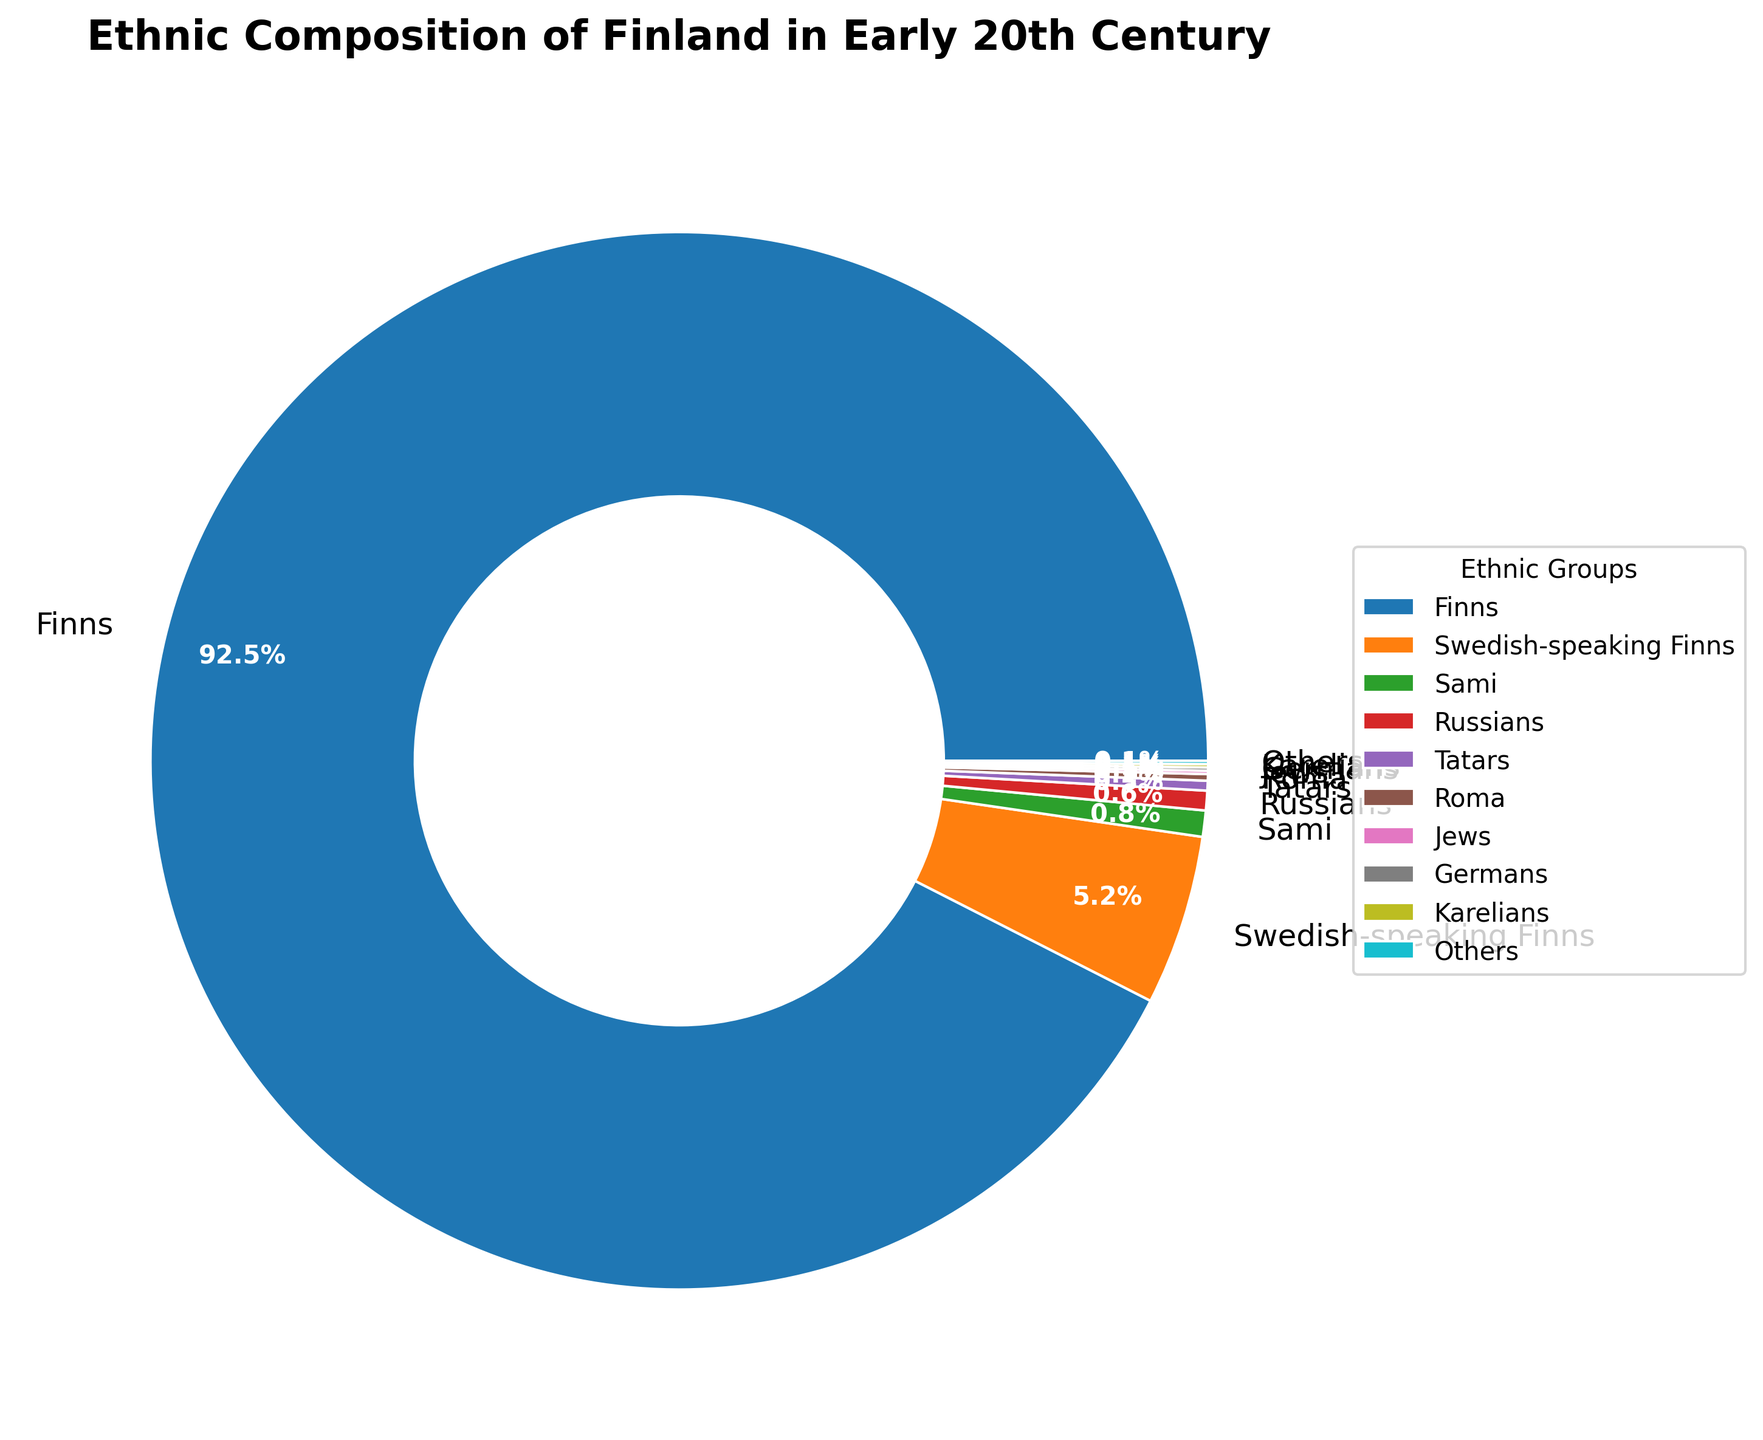What is the percentage of Finns in the ethnic composition of Finland in the early 20th century? The pie chart shows the "Finns" occupying the largest segment with a percentage label of 92.5%.
Answer: 92.5% How does the percentage of Swedish-speaking Finns compare to that of Sami? From the figure, it can be seen that the Swedish-speaking Finns make up 5.2%, while the Sami make up 0.8%. Therefore, the percentage of Swedish-speaking Finns is higher.
Answer: Swedish-speaking Finns have a higher percentage Which ethnic group follows the Finns in terms of population percentage? The pie chart indicates that after the Finns, who have the largest share, the Swedish-speaking Finns have the next largest share at 5.2%.
Answer: Swedish-speaking Finns What is the sum of the percentages of the smallest three ethnic groups? The smallest three groups represented on the chart, each at 0.1%, are Jews, Germans, and Karelians. Summing these gives 0.1% + 0.1% + 0.1% = 0.3%.
Answer: 0.3% How much more is the percentage of Finns compared to Russians? The percentage of Finns is 92.5%, and that of Russians is 0.6%. The difference is calculated as 92.5% - 0.6% = 91.9%.
Answer: 91.9% Which color represents the Tatars in the pie chart? The slice representing the Tatars is colored in a specific shade distinct from the other groups. In the chart's legend or visual representation, Tatars are indicated with a brownish color.
Answer: Brownish color If the percentage of Finns and Swedish-speaking Finns is combined, what fraction of the total population do they represent? Finns make up 92.5% and Swedish-speaking Finns 5.2%. Their combined percentage is 92.5% + 5.2% = 97.7%.
Answer: 97.7% Which ethnic group occupies the smallest segment in the pie chart? Multiple groups occupy 0.1% each, and thus share the smallest segment size equally. These groups are Jews, Germans, Karelians, and Others.
Answer: Jews, Germans, Karelians, Others What is the difference in the percentage between the largest and second-largest ethnic groups? The largest group is Finns at 92.5%, and the second-largest is Swedish-speaking Finns at 5.2%. The difference is 92.5% - 5.2% = 87.3%.
Answer: 87.3% Which ethnic group is represented by a red segment in the pie chart? By identifying the color scheme and legend, it is possible to determine that the red segment corresponds to the Russians.
Answer: Russians 